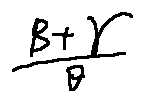<formula> <loc_0><loc_0><loc_500><loc_500>\frac { \beta + \gamma } { \theta }</formula> 